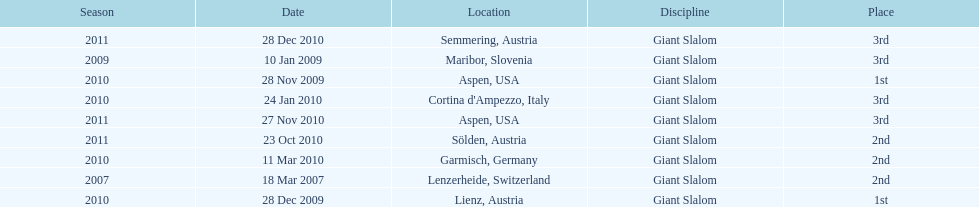Where was her first win? Aspen, USA. 